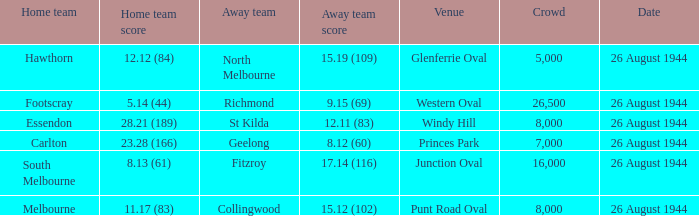Which Venue is the one for the footscray Home team? Western Oval. 